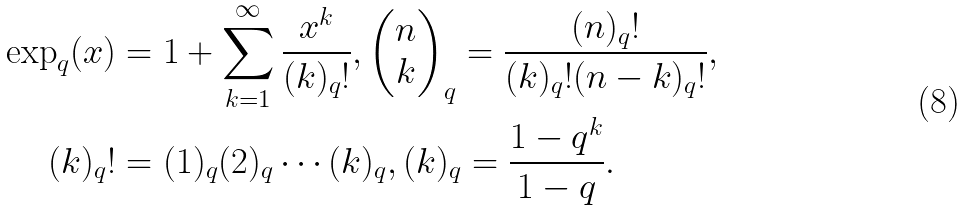<formula> <loc_0><loc_0><loc_500><loc_500>\exp _ { q } ( x ) & = 1 + \sum _ { k = 1 } ^ { \infty } \frac { x ^ { k } } { ( k ) _ { q } ! } , \begin{pmatrix} n \\ k \end{pmatrix} _ { q } = \frac { ( n ) _ { q } ! } { ( k ) _ { q } ! ( n - k ) _ { q } ! } , \\ ( k ) _ { q } ! & = ( 1 ) _ { q } ( 2 ) _ { q } \cdots ( k ) _ { q } , ( k ) _ { q } = \frac { 1 - q ^ { k } } { 1 - q } .</formula> 